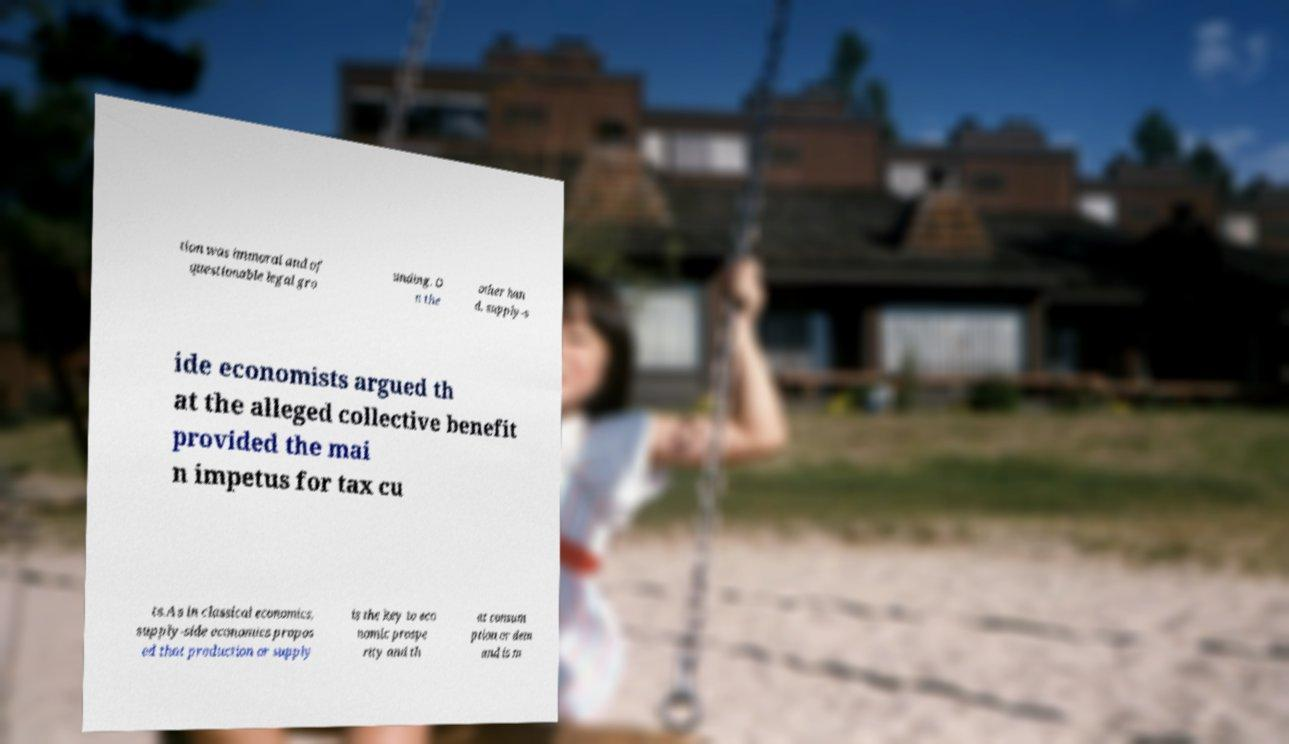What messages or text are displayed in this image? I need them in a readable, typed format. tion was immoral and of questionable legal gro unding. O n the other han d, supply-s ide economists argued th at the alleged collective benefit provided the mai n impetus for tax cu ts.As in classical economics, supply-side economics propos ed that production or supply is the key to eco nomic prospe rity and th at consum ption or dem and is m 